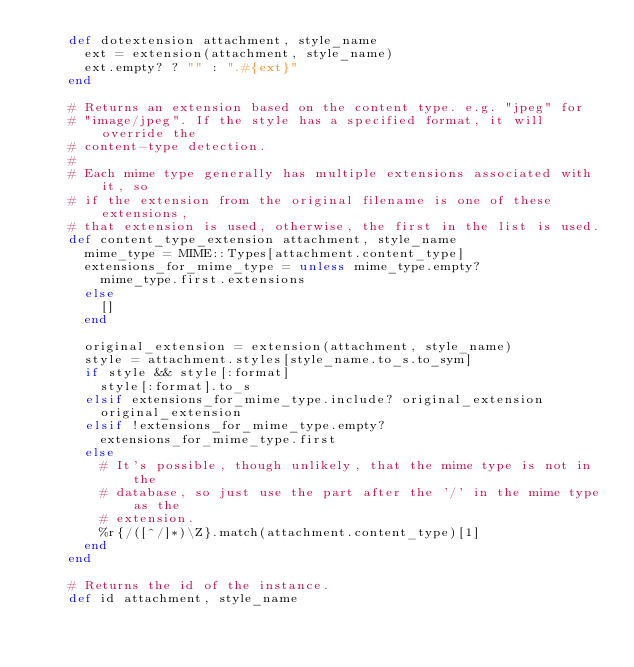<code> <loc_0><loc_0><loc_500><loc_500><_Ruby_>    def dotextension attachment, style_name
      ext = extension(attachment, style_name)
      ext.empty? ? "" : ".#{ext}"
    end

    # Returns an extension based on the content type. e.g. "jpeg" for
    # "image/jpeg". If the style has a specified format, it will override the
    # content-type detection.
    #
    # Each mime type generally has multiple extensions associated with it, so
    # if the extension from the original filename is one of these extensions,
    # that extension is used, otherwise, the first in the list is used.
    def content_type_extension attachment, style_name
      mime_type = MIME::Types[attachment.content_type]
      extensions_for_mime_type = unless mime_type.empty?
        mime_type.first.extensions
      else
        []
      end

      original_extension = extension(attachment, style_name)
      style = attachment.styles[style_name.to_s.to_sym]
      if style && style[:format]
        style[:format].to_s
      elsif extensions_for_mime_type.include? original_extension
        original_extension
      elsif !extensions_for_mime_type.empty?
        extensions_for_mime_type.first
      else
        # It's possible, though unlikely, that the mime type is not in the
        # database, so just use the part after the '/' in the mime type as the
        # extension.
        %r{/([^/]*)\Z}.match(attachment.content_type)[1]
      end
    end

    # Returns the id of the instance.
    def id attachment, style_name</code> 